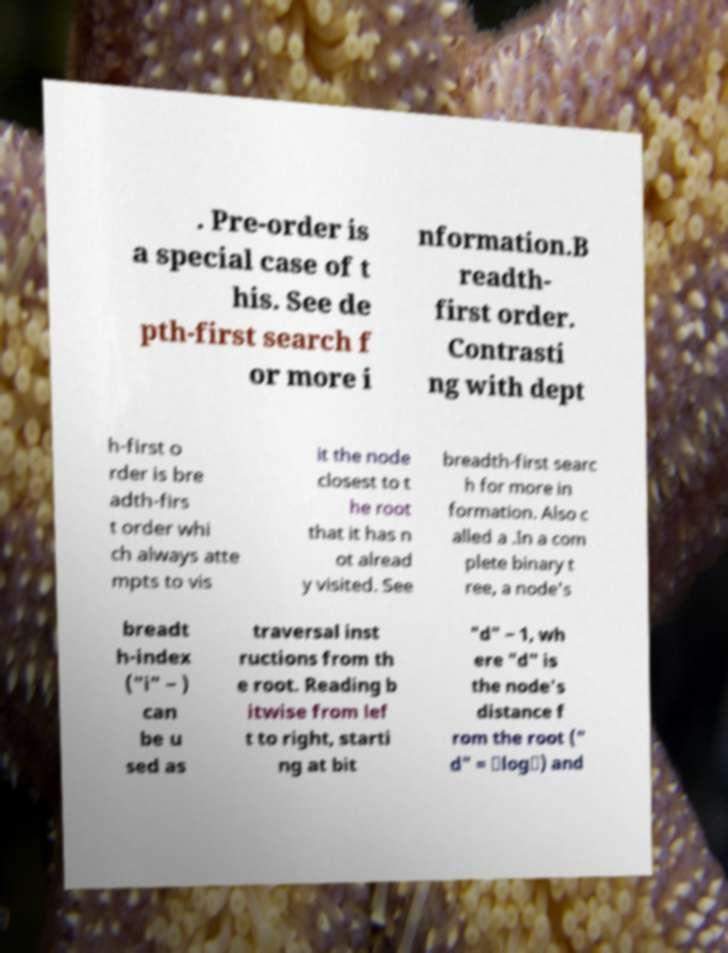Could you extract and type out the text from this image? . Pre-order is a special case of t his. See de pth-first search f or more i nformation.B readth- first order. Contrasti ng with dept h-first o rder is bre adth-firs t order whi ch always atte mpts to vis it the node closest to t he root that it has n ot alread y visited. See breadth-first searc h for more in formation. Also c alled a .In a com plete binary t ree, a node's breadt h-index ("i" − ) can be u sed as traversal inst ructions from th e root. Reading b itwise from lef t to right, starti ng at bit "d" − 1, wh ere "d" is the node's distance f rom the root (" d" = ⌊log⌋) and 